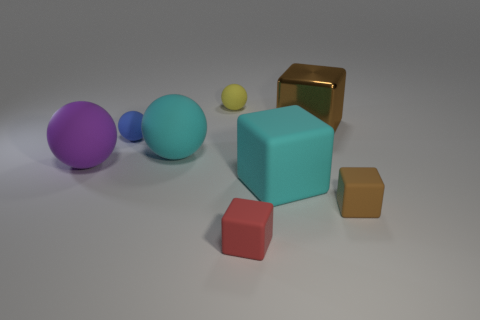What number of matte cubes have the same color as the shiny object?
Provide a short and direct response. 1. Are there any tiny blue rubber objects that are behind the cube that is behind the matte thing that is left of the blue ball?
Make the answer very short. No. Is the shape of the tiny matte object right of the large brown block the same as the cyan thing left of the red thing?
Provide a succinct answer. No. There is another tiny cube that is the same material as the tiny red block; what is its color?
Ensure brevity in your answer.  Brown. Is the number of tiny blue spheres that are in front of the big cyan sphere less than the number of yellow rubber objects?
Make the answer very short. Yes. There is a cube that is on the left side of the cyan object that is on the right side of the large cyan object behind the purple matte sphere; what is its size?
Offer a terse response. Small. Are the big cube that is in front of the brown metallic thing and the big brown block made of the same material?
Ensure brevity in your answer.  No. What is the material of the block that is the same color as the shiny thing?
Offer a terse response. Rubber. What number of things are either brown blocks or yellow matte cylinders?
Provide a succinct answer. 2. The cyan matte thing that is the same shape as the purple matte object is what size?
Provide a short and direct response. Large. 